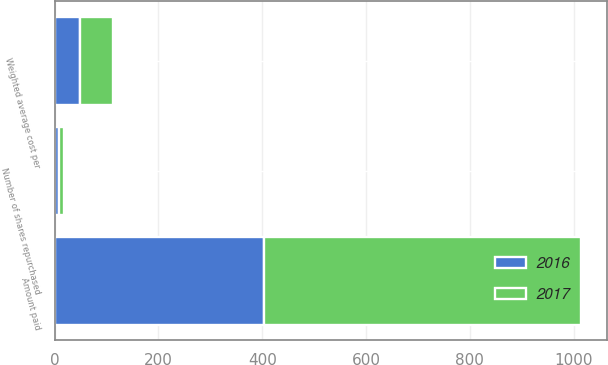Convert chart. <chart><loc_0><loc_0><loc_500><loc_500><stacked_bar_chart><ecel><fcel>Number of shares repurchased<fcel>Amount paid<fcel>Weighted average cost per<nl><fcel>2017<fcel>9.6<fcel>610.7<fcel>63.84<nl><fcel>2016<fcel>8.4<fcel>403.8<fcel>48.56<nl></chart> 